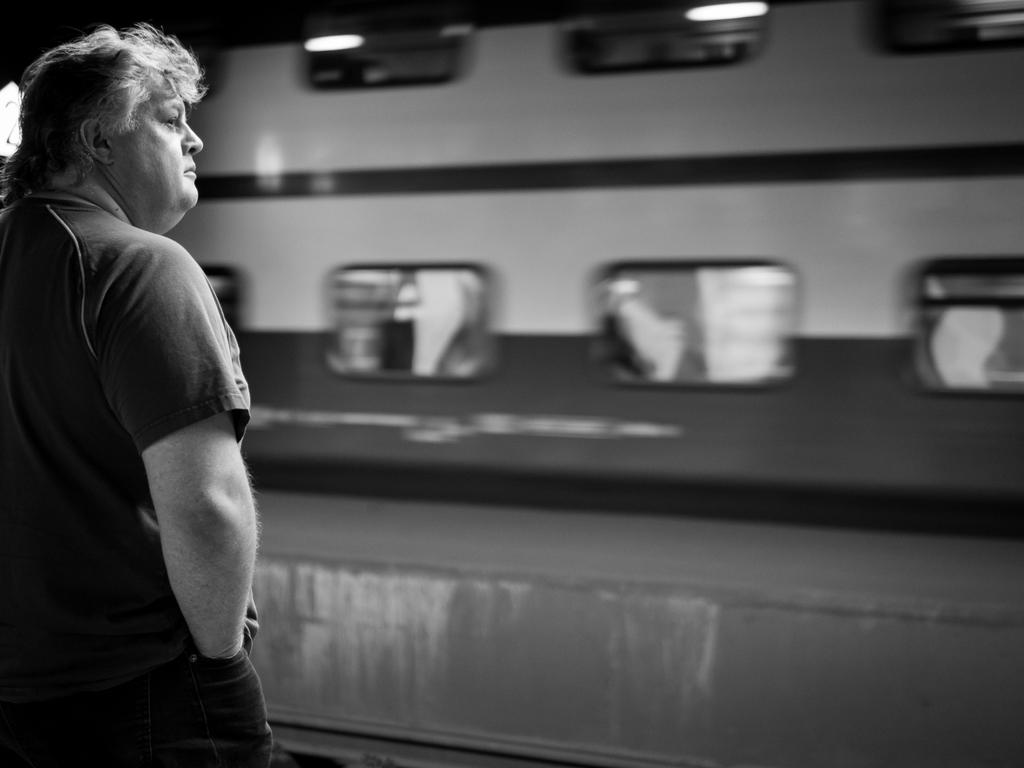What is the main subject of the image? There is a man standing in the image. Can you describe the background of the image? The background of the image is blurry. How many sheep can be seen grazing in the ocean in the image? There are no sheep or ocean present in the image; it features a man standing with a blurry background. 